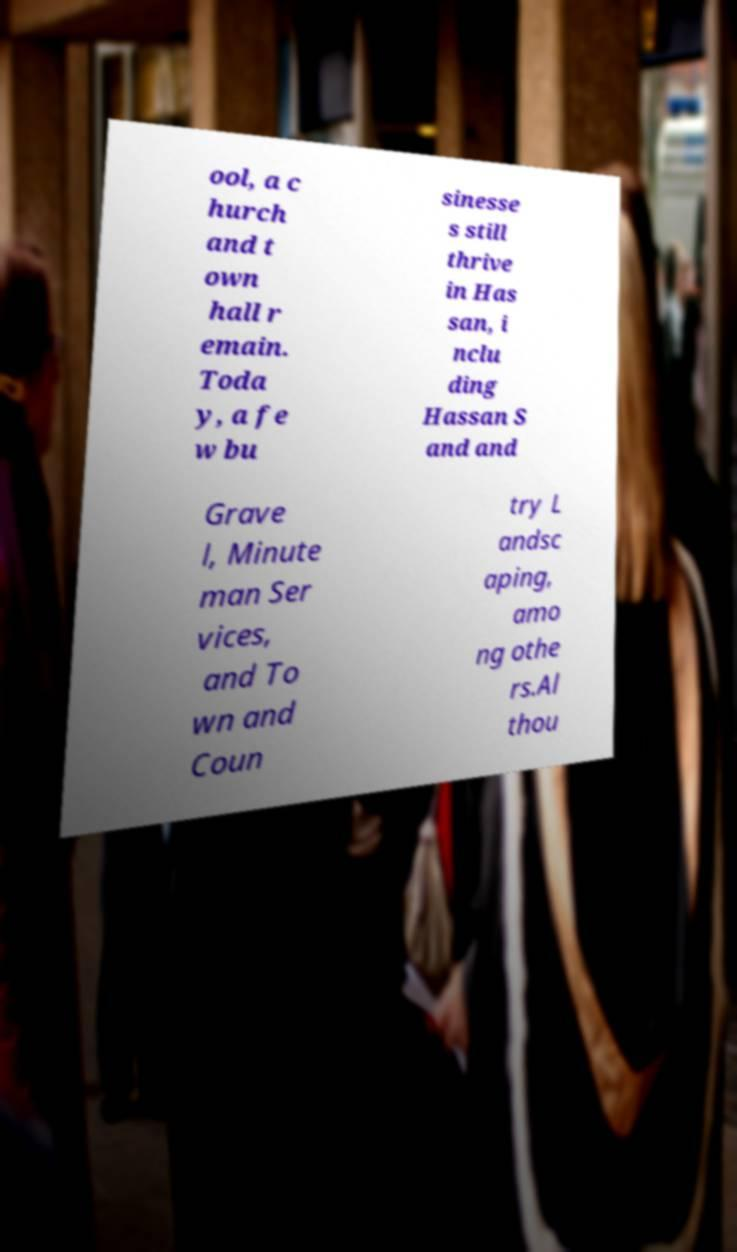Can you accurately transcribe the text from the provided image for me? ool, a c hurch and t own hall r emain. Toda y, a fe w bu sinesse s still thrive in Has san, i nclu ding Hassan S and and Grave l, Minute man Ser vices, and To wn and Coun try L andsc aping, amo ng othe rs.Al thou 